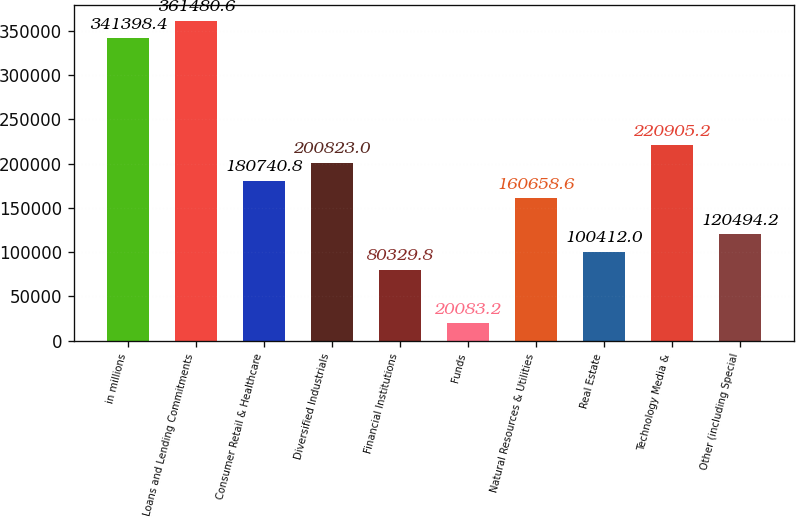Convert chart to OTSL. <chart><loc_0><loc_0><loc_500><loc_500><bar_chart><fcel>in millions<fcel>Loans and Lending Commitments<fcel>Consumer Retail & Healthcare<fcel>Diversified Industrials<fcel>Financial Institutions<fcel>Funds<fcel>Natural Resources & Utilities<fcel>Real Estate<fcel>Technology Media &<fcel>Other (including Special<nl><fcel>341398<fcel>361481<fcel>180741<fcel>200823<fcel>80329.8<fcel>20083.2<fcel>160659<fcel>100412<fcel>220905<fcel>120494<nl></chart> 